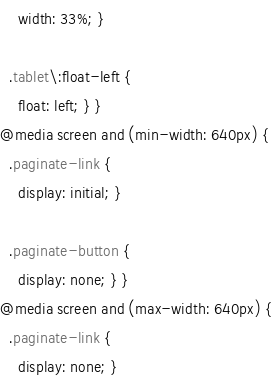Convert code to text. <code><loc_0><loc_0><loc_500><loc_500><_CSS_>    width: 33%; }

  .tablet\:float-left {
    float: left; } }
@media screen and (min-width: 640px) {
  .paginate-link {
    display: initial; }

  .paginate-button {
    display: none; } }
@media screen and (max-width: 640px) {
  .paginate-link {
    display: none; }
</code> 